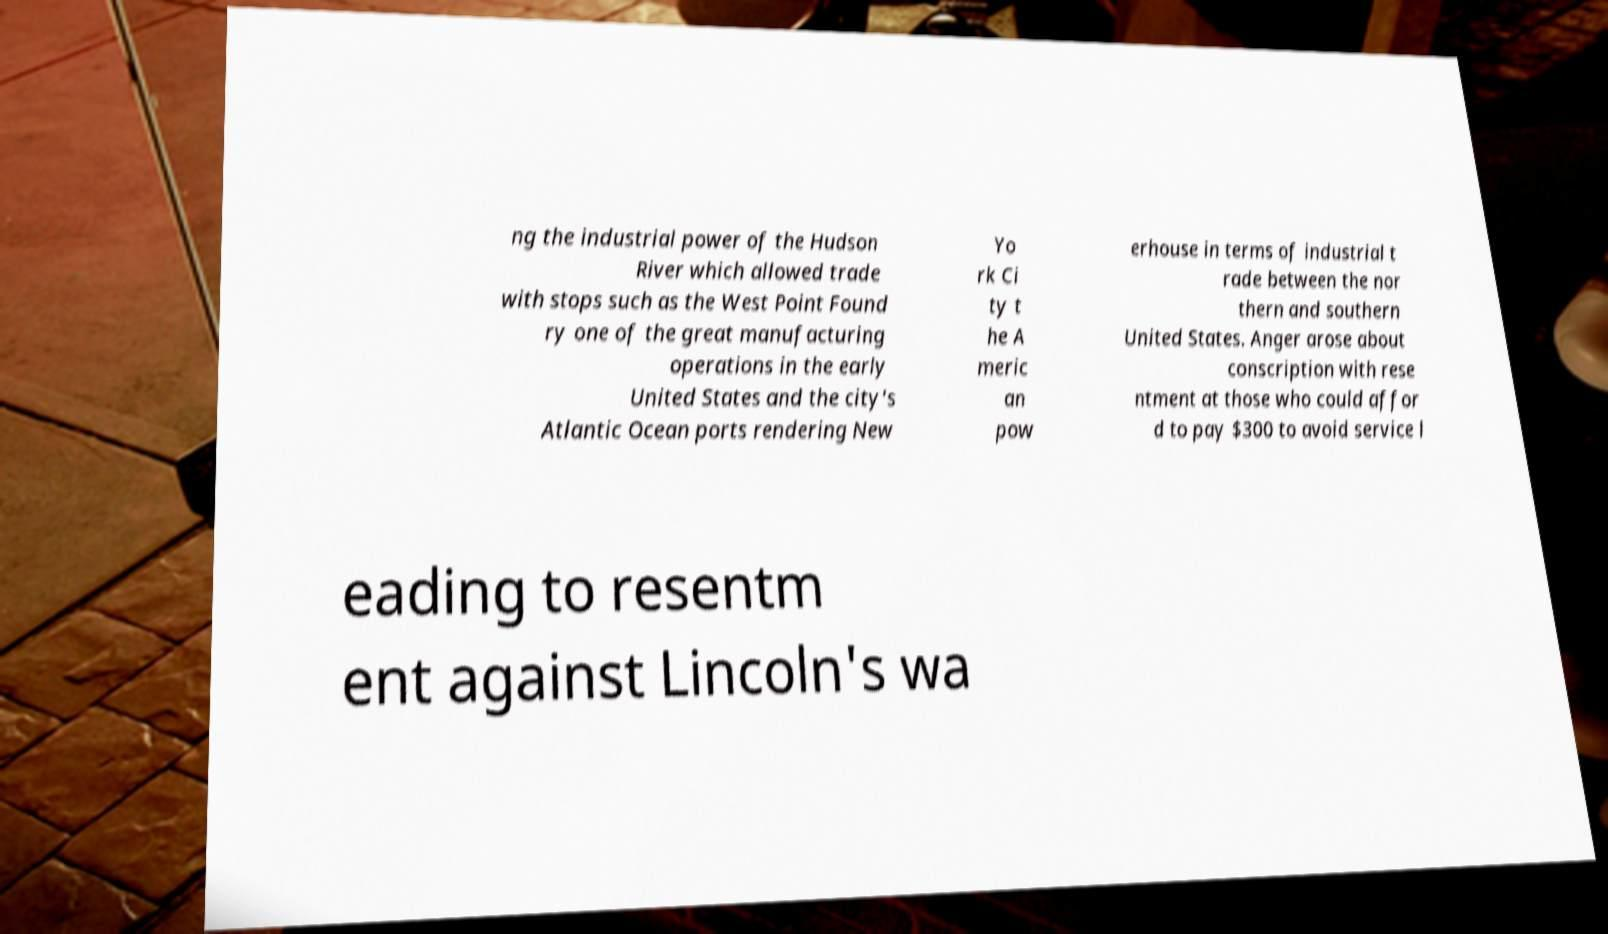Could you assist in decoding the text presented in this image and type it out clearly? ng the industrial power of the Hudson River which allowed trade with stops such as the West Point Found ry one of the great manufacturing operations in the early United States and the city's Atlantic Ocean ports rendering New Yo rk Ci ty t he A meric an pow erhouse in terms of industrial t rade between the nor thern and southern United States. Anger arose about conscription with rese ntment at those who could affor d to pay $300 to avoid service l eading to resentm ent against Lincoln's wa 